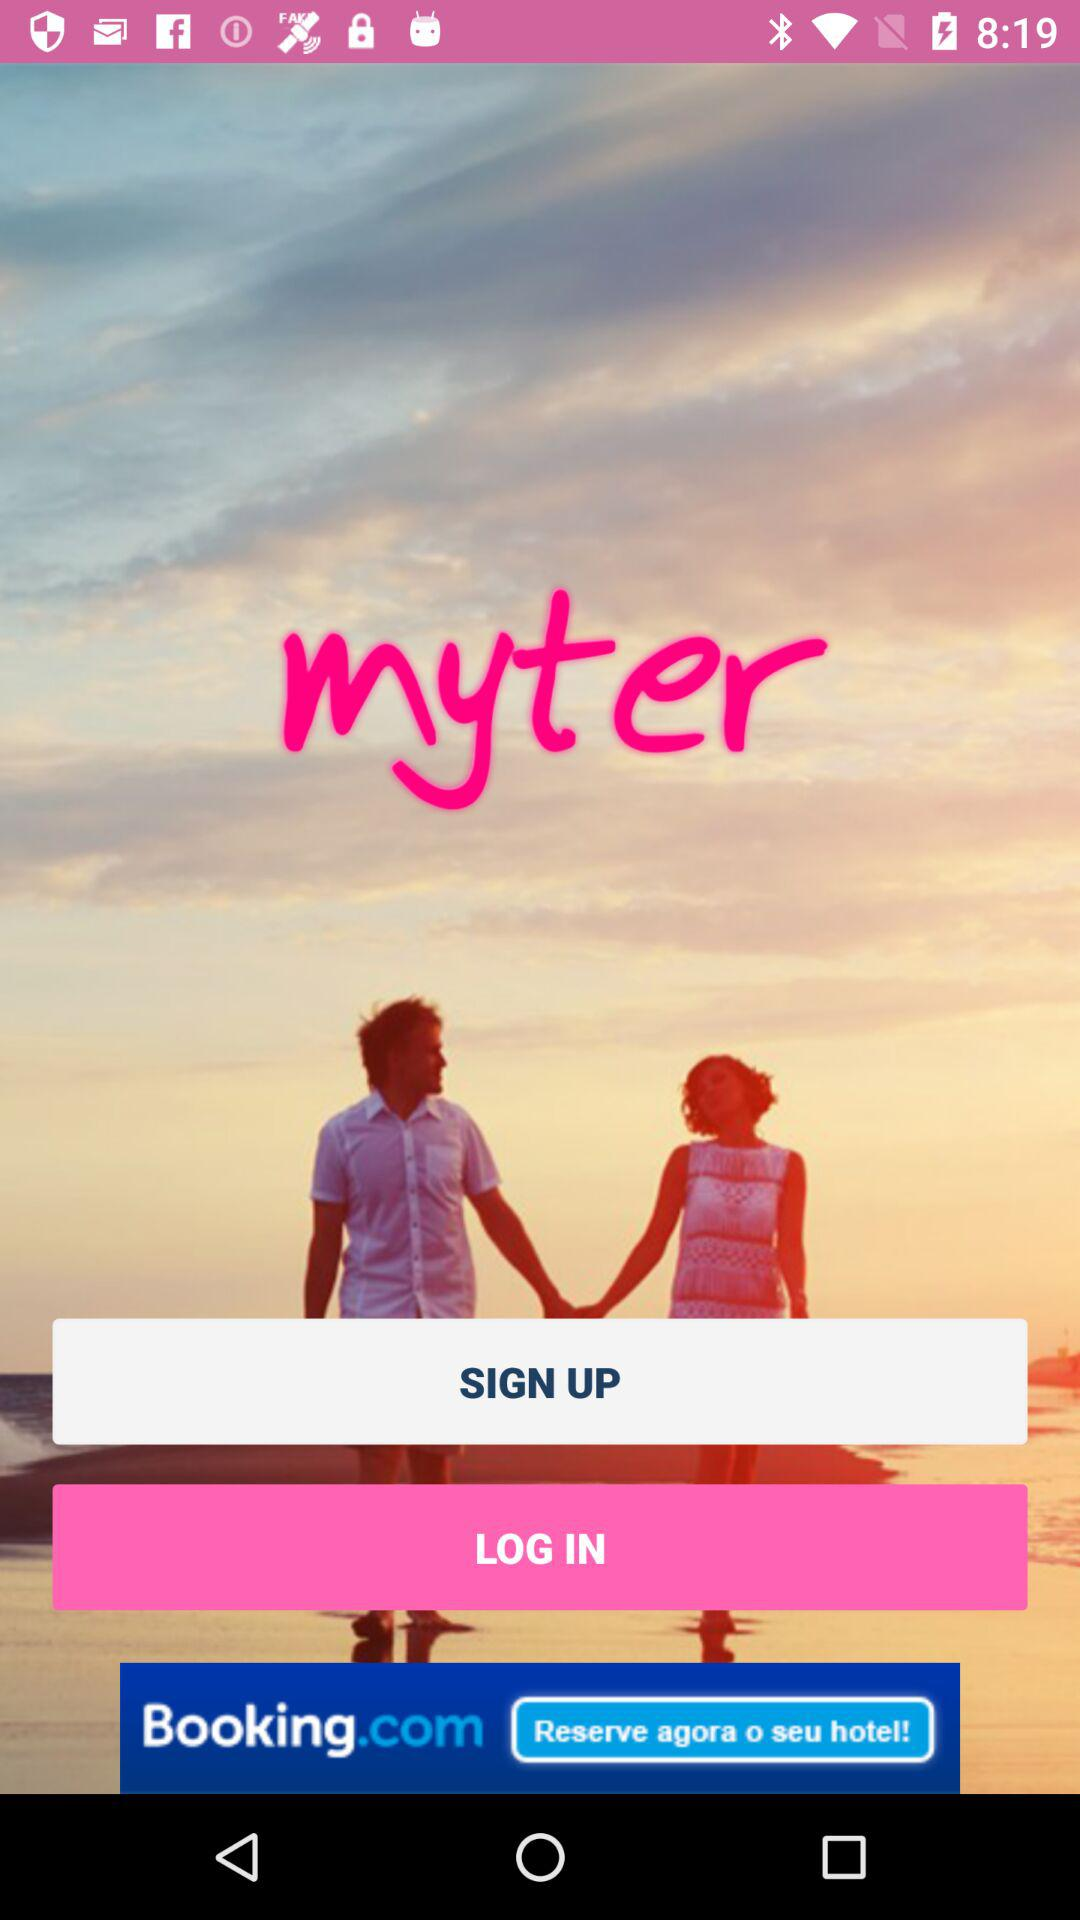What is the app name? The app name is "myter". 